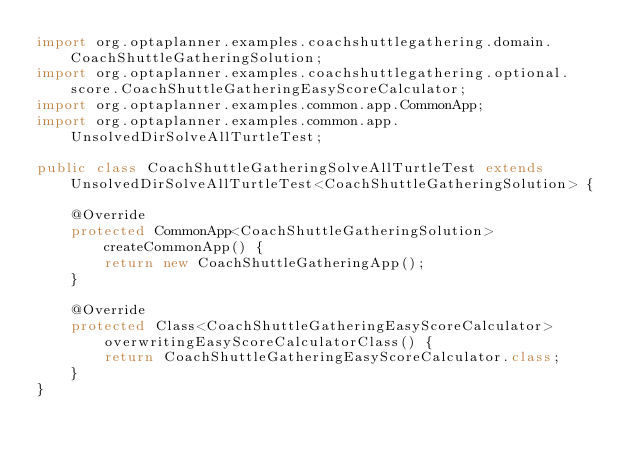Convert code to text. <code><loc_0><loc_0><loc_500><loc_500><_Java_>import org.optaplanner.examples.coachshuttlegathering.domain.CoachShuttleGatheringSolution;
import org.optaplanner.examples.coachshuttlegathering.optional.score.CoachShuttleGatheringEasyScoreCalculator;
import org.optaplanner.examples.common.app.CommonApp;
import org.optaplanner.examples.common.app.UnsolvedDirSolveAllTurtleTest;

public class CoachShuttleGatheringSolveAllTurtleTest extends UnsolvedDirSolveAllTurtleTest<CoachShuttleGatheringSolution> {

    @Override
    protected CommonApp<CoachShuttleGatheringSolution> createCommonApp() {
        return new CoachShuttleGatheringApp();
    }

    @Override
    protected Class<CoachShuttleGatheringEasyScoreCalculator> overwritingEasyScoreCalculatorClass() {
        return CoachShuttleGatheringEasyScoreCalculator.class;
    }
}
</code> 